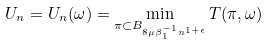Convert formula to latex. <formula><loc_0><loc_0><loc_500><loc_500>U _ { n } = U _ { n } ( \omega ) = \min _ { \pi \subset B _ { 8 \mu \beta ^ { - 1 } _ { 1 } n ^ { 1 + \epsilon } } } T ( \pi , \omega )</formula> 